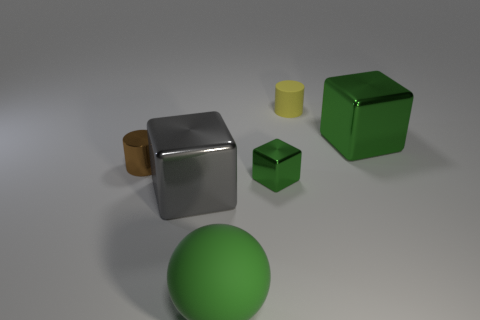What number of things are either small gray cylinders or yellow matte objects?
Offer a very short reply. 1. The cylinder that is to the right of the green metallic thing on the left side of the large cube that is to the right of the ball is made of what material?
Make the answer very short. Rubber. What material is the large green thing on the left side of the small block?
Provide a succinct answer. Rubber. Are there any other cylinders that have the same size as the metal cylinder?
Keep it short and to the point. Yes. There is a tiny shiny thing in front of the brown metal cylinder; is it the same color as the rubber ball?
Give a very brief answer. Yes. What number of cyan things are either matte things or cylinders?
Ensure brevity in your answer.  0. What number of big cubes are the same color as the small shiny block?
Make the answer very short. 1. Do the large gray thing and the small brown cylinder have the same material?
Ensure brevity in your answer.  Yes. How many blocks are on the right side of the cube that is to the left of the large rubber object?
Keep it short and to the point. 2. Does the brown cylinder have the same size as the gray shiny thing?
Your answer should be compact. No. 